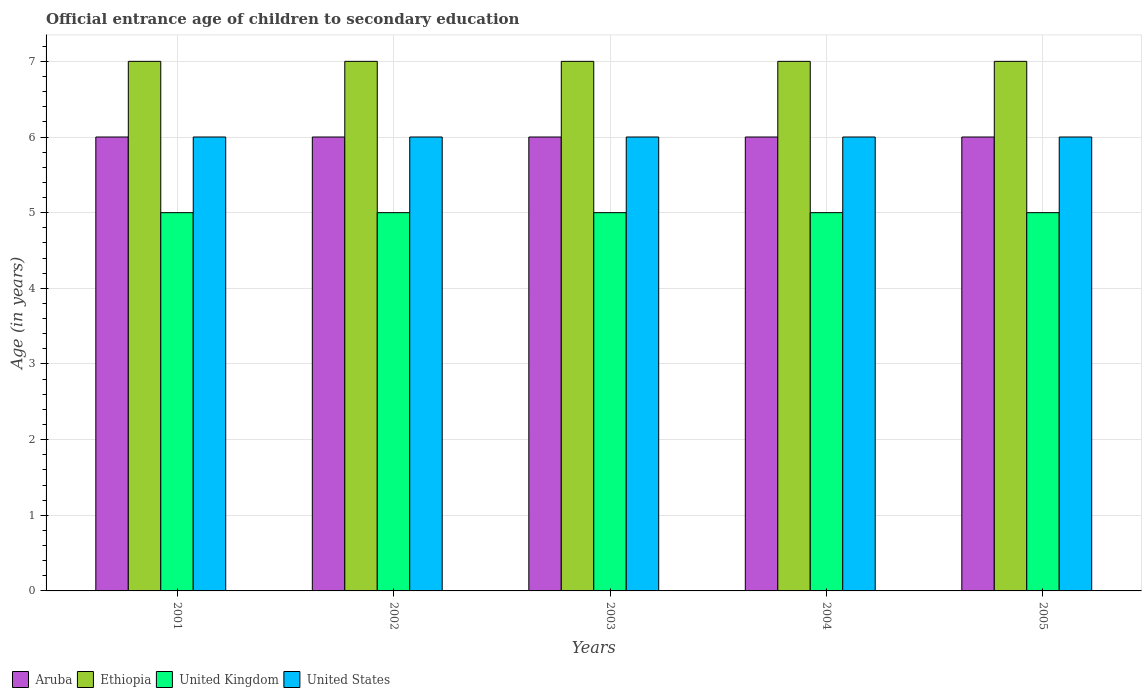How many different coloured bars are there?
Offer a very short reply. 4. How many groups of bars are there?
Provide a short and direct response. 5. How many bars are there on the 1st tick from the left?
Your answer should be compact. 4. In how many cases, is the number of bars for a given year not equal to the number of legend labels?
Your response must be concise. 0. What is the secondary school starting age of children in Ethiopia in 2004?
Ensure brevity in your answer.  7. Across all years, what is the minimum secondary school starting age of children in United States?
Offer a very short reply. 6. In which year was the secondary school starting age of children in United States maximum?
Your answer should be compact. 2001. What is the total secondary school starting age of children in United States in the graph?
Make the answer very short. 30. What is the difference between the secondary school starting age of children in United States in 2002 and that in 2004?
Offer a terse response. 0. What is the average secondary school starting age of children in Aruba per year?
Make the answer very short. 6. In the year 2005, what is the difference between the secondary school starting age of children in United Kingdom and secondary school starting age of children in Aruba?
Make the answer very short. -1. In how many years, is the secondary school starting age of children in United States greater than 1.2 years?
Provide a succinct answer. 5. Is the secondary school starting age of children in Aruba in 2004 less than that in 2005?
Make the answer very short. No. Is the difference between the secondary school starting age of children in United Kingdom in 2003 and 2005 greater than the difference between the secondary school starting age of children in Aruba in 2003 and 2005?
Your response must be concise. No. What is the difference between the highest and the second highest secondary school starting age of children in United Kingdom?
Offer a very short reply. 0. What is the difference between the highest and the lowest secondary school starting age of children in Aruba?
Make the answer very short. 0. What does the 1st bar from the left in 2004 represents?
Ensure brevity in your answer.  Aruba. Is it the case that in every year, the sum of the secondary school starting age of children in United States and secondary school starting age of children in Aruba is greater than the secondary school starting age of children in United Kingdom?
Offer a terse response. Yes. How many bars are there?
Ensure brevity in your answer.  20. Are all the bars in the graph horizontal?
Keep it short and to the point. No. How many years are there in the graph?
Offer a very short reply. 5. Are the values on the major ticks of Y-axis written in scientific E-notation?
Offer a very short reply. No. Where does the legend appear in the graph?
Make the answer very short. Bottom left. How many legend labels are there?
Offer a terse response. 4. How are the legend labels stacked?
Ensure brevity in your answer.  Horizontal. What is the title of the graph?
Offer a very short reply. Official entrance age of children to secondary education. What is the label or title of the X-axis?
Your response must be concise. Years. What is the label or title of the Y-axis?
Your answer should be very brief. Age (in years). What is the Age (in years) of Aruba in 2001?
Provide a short and direct response. 6. What is the Age (in years) of United Kingdom in 2001?
Keep it short and to the point. 5. What is the Age (in years) in United States in 2001?
Keep it short and to the point. 6. What is the Age (in years) in Aruba in 2002?
Provide a short and direct response. 6. What is the Age (in years) in United Kingdom in 2002?
Offer a very short reply. 5. What is the Age (in years) of Aruba in 2003?
Keep it short and to the point. 6. What is the Age (in years) of Ethiopia in 2003?
Keep it short and to the point. 7. What is the Age (in years) in United Kingdom in 2003?
Keep it short and to the point. 5. What is the Age (in years) in United States in 2003?
Your answer should be very brief. 6. What is the Age (in years) of United Kingdom in 2004?
Your answer should be compact. 5. What is the Age (in years) in Aruba in 2005?
Make the answer very short. 6. What is the Age (in years) of United Kingdom in 2005?
Make the answer very short. 5. What is the Age (in years) of United States in 2005?
Your answer should be very brief. 6. Across all years, what is the maximum Age (in years) in Aruba?
Your answer should be very brief. 6. Across all years, what is the maximum Age (in years) of Ethiopia?
Provide a succinct answer. 7. Across all years, what is the maximum Age (in years) of United States?
Provide a short and direct response. 6. Across all years, what is the minimum Age (in years) of Aruba?
Give a very brief answer. 6. Across all years, what is the minimum Age (in years) in Ethiopia?
Offer a terse response. 7. Across all years, what is the minimum Age (in years) of United Kingdom?
Keep it short and to the point. 5. What is the total Age (in years) in Ethiopia in the graph?
Ensure brevity in your answer.  35. What is the difference between the Age (in years) in Aruba in 2001 and that in 2003?
Give a very brief answer. 0. What is the difference between the Age (in years) of Ethiopia in 2001 and that in 2003?
Offer a terse response. 0. What is the difference between the Age (in years) of United States in 2001 and that in 2003?
Offer a very short reply. 0. What is the difference between the Age (in years) in United States in 2001 and that in 2004?
Your response must be concise. 0. What is the difference between the Age (in years) in United States in 2001 and that in 2005?
Your answer should be compact. 0. What is the difference between the Age (in years) in United States in 2002 and that in 2003?
Ensure brevity in your answer.  0. What is the difference between the Age (in years) in Aruba in 2002 and that in 2004?
Give a very brief answer. 0. What is the difference between the Age (in years) in Ethiopia in 2002 and that in 2004?
Your answer should be very brief. 0. What is the difference between the Age (in years) of United Kingdom in 2002 and that in 2004?
Your response must be concise. 0. What is the difference between the Age (in years) of Ethiopia in 2002 and that in 2005?
Provide a short and direct response. 0. What is the difference between the Age (in years) in United Kingdom in 2003 and that in 2004?
Provide a succinct answer. 0. What is the difference between the Age (in years) in Aruba in 2003 and that in 2005?
Your response must be concise. 0. What is the difference between the Age (in years) of Ethiopia in 2004 and that in 2005?
Your answer should be compact. 0. What is the difference between the Age (in years) of Aruba in 2001 and the Age (in years) of United Kingdom in 2002?
Give a very brief answer. 1. What is the difference between the Age (in years) of Aruba in 2001 and the Age (in years) of United States in 2002?
Provide a succinct answer. 0. What is the difference between the Age (in years) in Ethiopia in 2001 and the Age (in years) in United States in 2002?
Your answer should be compact. 1. What is the difference between the Age (in years) of Aruba in 2001 and the Age (in years) of United Kingdom in 2003?
Make the answer very short. 1. What is the difference between the Age (in years) of Aruba in 2001 and the Age (in years) of United Kingdom in 2004?
Ensure brevity in your answer.  1. What is the difference between the Age (in years) in Aruba in 2001 and the Age (in years) in United States in 2004?
Offer a terse response. 0. What is the difference between the Age (in years) in Ethiopia in 2001 and the Age (in years) in United States in 2004?
Provide a succinct answer. 1. What is the difference between the Age (in years) of United Kingdom in 2001 and the Age (in years) of United States in 2004?
Make the answer very short. -1. What is the difference between the Age (in years) of Aruba in 2001 and the Age (in years) of Ethiopia in 2005?
Keep it short and to the point. -1. What is the difference between the Age (in years) in Aruba in 2001 and the Age (in years) in United Kingdom in 2005?
Provide a succinct answer. 1. What is the difference between the Age (in years) of Aruba in 2002 and the Age (in years) of Ethiopia in 2003?
Your response must be concise. -1. What is the difference between the Age (in years) in Aruba in 2002 and the Age (in years) in United Kingdom in 2003?
Keep it short and to the point. 1. What is the difference between the Age (in years) of Ethiopia in 2002 and the Age (in years) of United States in 2003?
Ensure brevity in your answer.  1. What is the difference between the Age (in years) in United Kingdom in 2002 and the Age (in years) in United States in 2003?
Make the answer very short. -1. What is the difference between the Age (in years) in United Kingdom in 2002 and the Age (in years) in United States in 2004?
Offer a very short reply. -1. What is the difference between the Age (in years) of Aruba in 2002 and the Age (in years) of Ethiopia in 2005?
Your answer should be very brief. -1. What is the difference between the Age (in years) of Aruba in 2002 and the Age (in years) of United States in 2005?
Ensure brevity in your answer.  0. What is the difference between the Age (in years) of United Kingdom in 2002 and the Age (in years) of United States in 2005?
Provide a succinct answer. -1. What is the difference between the Age (in years) of Aruba in 2003 and the Age (in years) of Ethiopia in 2004?
Your answer should be compact. -1. What is the difference between the Age (in years) in Aruba in 2003 and the Age (in years) in United Kingdom in 2004?
Your answer should be compact. 1. What is the difference between the Age (in years) of Ethiopia in 2003 and the Age (in years) of United Kingdom in 2004?
Offer a very short reply. 2. What is the difference between the Age (in years) in Ethiopia in 2004 and the Age (in years) in United States in 2005?
Provide a short and direct response. 1. What is the average Age (in years) in Aruba per year?
Your response must be concise. 6. What is the average Age (in years) of Ethiopia per year?
Offer a very short reply. 7. What is the average Age (in years) of United Kingdom per year?
Your response must be concise. 5. In the year 2001, what is the difference between the Age (in years) in Aruba and Age (in years) in United Kingdom?
Your response must be concise. 1. In the year 2001, what is the difference between the Age (in years) in Aruba and Age (in years) in United States?
Your answer should be compact. 0. In the year 2002, what is the difference between the Age (in years) in Aruba and Age (in years) in Ethiopia?
Your response must be concise. -1. In the year 2002, what is the difference between the Age (in years) in Aruba and Age (in years) in United Kingdom?
Offer a terse response. 1. In the year 2002, what is the difference between the Age (in years) of Ethiopia and Age (in years) of United States?
Offer a very short reply. 1. In the year 2003, what is the difference between the Age (in years) in Aruba and Age (in years) in United Kingdom?
Your response must be concise. 1. In the year 2003, what is the difference between the Age (in years) of Aruba and Age (in years) of United States?
Your answer should be very brief. 0. In the year 2004, what is the difference between the Age (in years) of Aruba and Age (in years) of Ethiopia?
Keep it short and to the point. -1. In the year 2004, what is the difference between the Age (in years) of Aruba and Age (in years) of United Kingdom?
Offer a terse response. 1. In the year 2004, what is the difference between the Age (in years) in Aruba and Age (in years) in United States?
Provide a succinct answer. 0. In the year 2004, what is the difference between the Age (in years) in Ethiopia and Age (in years) in United States?
Offer a very short reply. 1. In the year 2005, what is the difference between the Age (in years) of Aruba and Age (in years) of Ethiopia?
Keep it short and to the point. -1. In the year 2005, what is the difference between the Age (in years) in Ethiopia and Age (in years) in United Kingdom?
Ensure brevity in your answer.  2. In the year 2005, what is the difference between the Age (in years) in United Kingdom and Age (in years) in United States?
Ensure brevity in your answer.  -1. What is the ratio of the Age (in years) of Aruba in 2001 to that in 2002?
Provide a short and direct response. 1. What is the ratio of the Age (in years) of United Kingdom in 2001 to that in 2002?
Ensure brevity in your answer.  1. What is the ratio of the Age (in years) of United States in 2001 to that in 2002?
Your answer should be very brief. 1. What is the ratio of the Age (in years) in United Kingdom in 2001 to that in 2003?
Make the answer very short. 1. What is the ratio of the Age (in years) in United States in 2001 to that in 2003?
Make the answer very short. 1. What is the ratio of the Age (in years) of Ethiopia in 2001 to that in 2004?
Offer a terse response. 1. What is the ratio of the Age (in years) of United Kingdom in 2001 to that in 2004?
Your response must be concise. 1. What is the ratio of the Age (in years) in United States in 2001 to that in 2004?
Offer a very short reply. 1. What is the ratio of the Age (in years) of Aruba in 2001 to that in 2005?
Make the answer very short. 1. What is the ratio of the Age (in years) in Ethiopia in 2001 to that in 2005?
Ensure brevity in your answer.  1. What is the ratio of the Age (in years) in United Kingdom in 2001 to that in 2005?
Give a very brief answer. 1. What is the ratio of the Age (in years) in Aruba in 2002 to that in 2003?
Offer a terse response. 1. What is the ratio of the Age (in years) of Ethiopia in 2002 to that in 2003?
Give a very brief answer. 1. What is the ratio of the Age (in years) of Aruba in 2002 to that in 2004?
Give a very brief answer. 1. What is the ratio of the Age (in years) of Ethiopia in 2002 to that in 2004?
Give a very brief answer. 1. What is the ratio of the Age (in years) in United Kingdom in 2002 to that in 2004?
Provide a short and direct response. 1. What is the ratio of the Age (in years) of Ethiopia in 2002 to that in 2005?
Your answer should be compact. 1. What is the ratio of the Age (in years) of United Kingdom in 2002 to that in 2005?
Your answer should be compact. 1. What is the ratio of the Age (in years) in Ethiopia in 2003 to that in 2004?
Provide a short and direct response. 1. What is the ratio of the Age (in years) of United Kingdom in 2003 to that in 2004?
Give a very brief answer. 1. What is the ratio of the Age (in years) in United Kingdom in 2003 to that in 2005?
Make the answer very short. 1. What is the ratio of the Age (in years) in United States in 2004 to that in 2005?
Give a very brief answer. 1. What is the difference between the highest and the second highest Age (in years) in United States?
Ensure brevity in your answer.  0. What is the difference between the highest and the lowest Age (in years) in Aruba?
Ensure brevity in your answer.  0. What is the difference between the highest and the lowest Age (in years) of Ethiopia?
Your response must be concise. 0. What is the difference between the highest and the lowest Age (in years) of United Kingdom?
Make the answer very short. 0. 